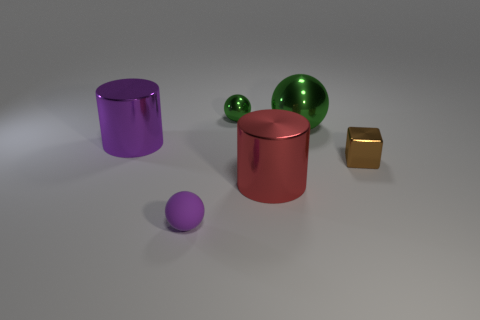Are there any tiny balls of the same color as the tiny cube?
Provide a short and direct response. No. The brown block is what size?
Your response must be concise. Small. Does the big red cylinder have the same material as the brown block?
Provide a succinct answer. Yes. There is a metal cylinder that is left of the sphere behind the big green ball; what number of things are behind it?
Offer a terse response. 2. The large thing that is on the left side of the purple sphere has what shape?
Provide a succinct answer. Cylinder. What number of other things are the same material as the big ball?
Ensure brevity in your answer.  4. Do the big sphere and the small metallic ball have the same color?
Make the answer very short. Yes. Are there fewer big cylinders in front of the tiny rubber thing than tiny spheres right of the small brown thing?
Provide a short and direct response. No. What is the color of the other metal thing that is the same shape as the big green thing?
Ensure brevity in your answer.  Green. Does the cylinder that is behind the red cylinder have the same size as the tiny green metal thing?
Keep it short and to the point. No. 